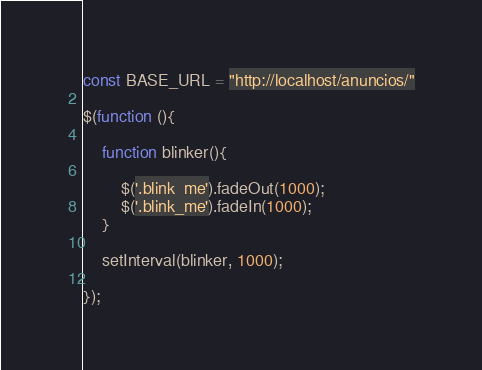<code> <loc_0><loc_0><loc_500><loc_500><_JavaScript_>const BASE_URL = "http://localhost/anuncios/"

$(function (){

	function blinker(){

		$('.blink_me').fadeOut(1000);
		$('.blink_me').fadeIn(1000);
	}

	setInterval(blinker, 1000);

});
</code> 